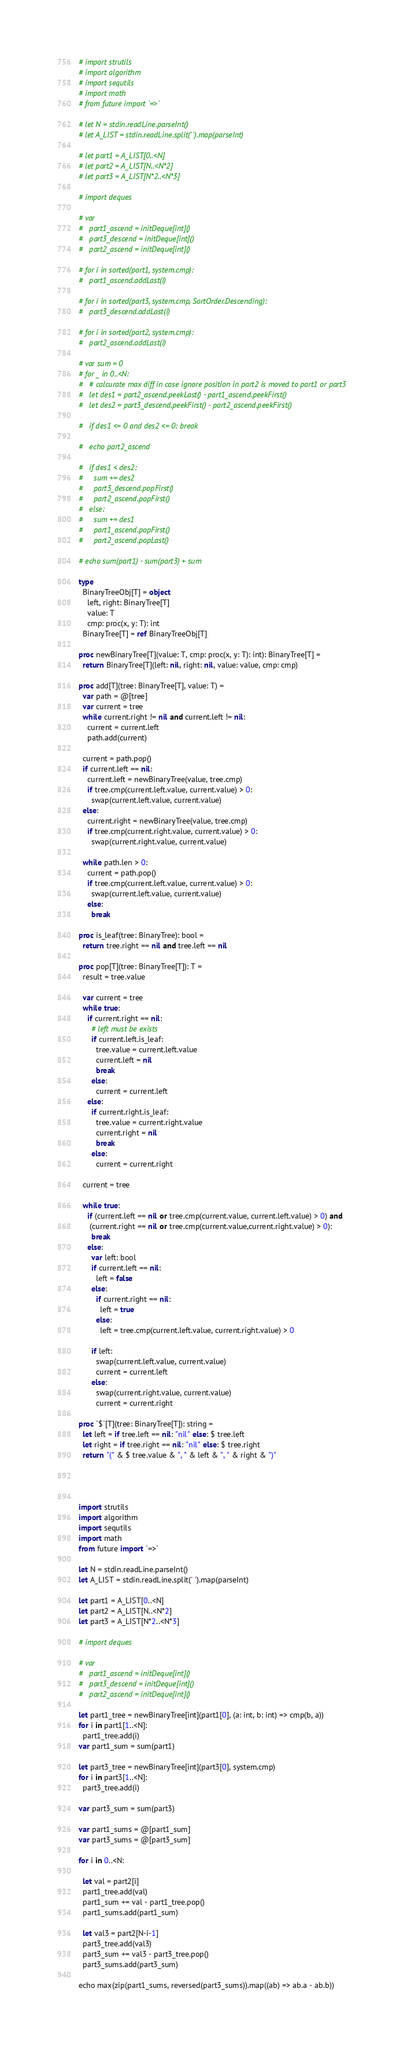<code> <loc_0><loc_0><loc_500><loc_500><_Nim_># import strutils
# import algorithm
# import sequtils
# import math
# from future import `=>`
 
# let N = stdin.readLine.parseInt()
# let A_LIST = stdin.readLine.split(' ').map(parseInt)
 
# let part1 = A_LIST[0..<N]
# let part2 = A_LIST[N..<N*2]
# let part3 = A_LIST[N*2..<N*3]
 
# import deques
 
# var 
#   part1_ascend = initDeque[int]()
#   part3_descend = initDeque[int]()
#   part2_ascend = initDeque[int]()
 
# for i in sorted(part1, system.cmp):
#   part1_ascend.addLast(i)
 
# for i in sorted(part3, system.cmp, SortOrder.Descending):
#   part3_descend.addLast(i)
 
# for i in sorted(part2, system.cmp):
#   part2_ascend.addLast(i)
 
# var sum = 0
# for _ in 0..<N:
#   # calcurate max diff in case ignore position in part2 is moved to part1 or part3
#   let des1 = part2_ascend.peekLast() - part1_ascend.peekFirst()
#   let des2 = part3_descend.peekFirst() - part2_ascend.peekFirst()
 
#   if des1 <= 0 and des2 <= 0: break
 
#   echo part2_ascend
 
#   if des1 < des2:
#     sum += des2
#     part3_descend.popFirst()
#     part2_ascend.popFirst()
#   else:
#     sum += des1
#     part1_ascend.popFirst()
#     part2_ascend.popLast()
 
# echo sum(part1) - sum(part3) + sum

type
  BinaryTreeObj[T] = object
    left, right: BinaryTree[T]
    value: T
    cmp: proc(x, y: T): int
  BinaryTree[T] = ref BinaryTreeObj[T]

proc newBinaryTree[T](value: T, cmp: proc(x, y: T): int): BinaryTree[T] =
  return BinaryTree[T](left: nil, right: nil, value: value, cmp: cmp)

proc add[T](tree: BinaryTree[T], value: T) =
  var path = @[tree]
  var current = tree 
  while current.right != nil and current.left != nil:
    current = current.left
    path.add(current)
  
  current = path.pop()
  if current.left == nil:
    current.left = newBinaryTree(value, tree.cmp)
    if tree.cmp(current.left.value, current.value) > 0:
      swap(current.left.value, current.value)
  else:
    current.right = newBinaryTree(value, tree.cmp)
    if tree.cmp(current.right.value, current.value) > 0:
      swap(current.right.value, current.value)

  while path.len > 0:
    current = path.pop()
    if tree.cmp(current.left.value, current.value) > 0:
      swap(current.left.value, current.value)
    else:
      break

proc is_leaf(tree: BinaryTree): bool =
  return tree.right == nil and tree.left == nil

proc pop[T](tree: BinaryTree[T]): T =
  result = tree.value

  var current = tree
  while true:
    if current.right == nil:
      # left must be exists
      if current.left.is_leaf:
        tree.value = current.left.value
        current.left = nil
        break
      else:
        current = current.left
    else:
      if current.right.is_leaf:
        tree.value = current.right.value
        current.right = nil
        break
      else:
        current = current.right

  current = tree

  while true:
    if (current.left == nil or tree.cmp(current.value, current.left.value) > 0) and
     (current.right == nil or tree.cmp(current.value,current.right.value) > 0):
      break
    else:
      var left: bool
      if current.left == nil:
        left = false
      else:
        if current.right == nil:
          left = true
        else:
          left = tree.cmp(current.left.value, current.right.value) > 0

      if left:
        swap(current.left.value, current.value)
        current = current.left
      else:
        swap(current.right.value, current.value)
        current = current.right

proc `$`[T](tree: BinaryTree[T]): string =
  let left = if tree.left == nil: "nil" else: $ tree.left
  let right = if tree.right == nil: "nil" else: $ tree.right
  return "(" & $ tree.value & ", " & left & ", " & right & ")"



 
import strutils
import algorithm
import sequtils
import math
from future import `=>`
 
let N = stdin.readLine.parseInt()
let A_LIST = stdin.readLine.split(' ').map(parseInt)
 
let part1 = A_LIST[0..<N]
let part2 = A_LIST[N..<N*2]
let part3 = A_LIST[N*2..<N*3]
 
# import deques
 
# var 
#   part1_ascend = initDeque[int]()
#   part3_descend = initDeque[int]()
#   part2_ascend = initDeque[int]()
 
let part1_tree = newBinaryTree[int](part1[0], (a: int, b: int) => cmp(b, a))
for i in part1[1..<N]:
  part1_tree.add(i)
var part1_sum = sum(part1)

let part3_tree = newBinaryTree[int](part3[0], system.cmp)
for i in part3[1..<N]:
  part3_tree.add(i)

var part3_sum = sum(part3)
 
var part1_sums = @[part1_sum]
var part3_sums = @[part3_sum]
 
for i in 0..<N:

  let val = part2[i] 
  part1_tree.add(val)
  part1_sum += val - part1_tree.pop()
  part1_sums.add(part1_sum)

  let val3 = part2[N-i-1] 
  part3_tree.add(val3)
  part3_sum += val3 - part3_tree.pop()
  part3_sums.add(part3_sum)

echo max(zip(part1_sums, reversed(part3_sums)).map((ab) => ab.a - ab.b))
</code> 